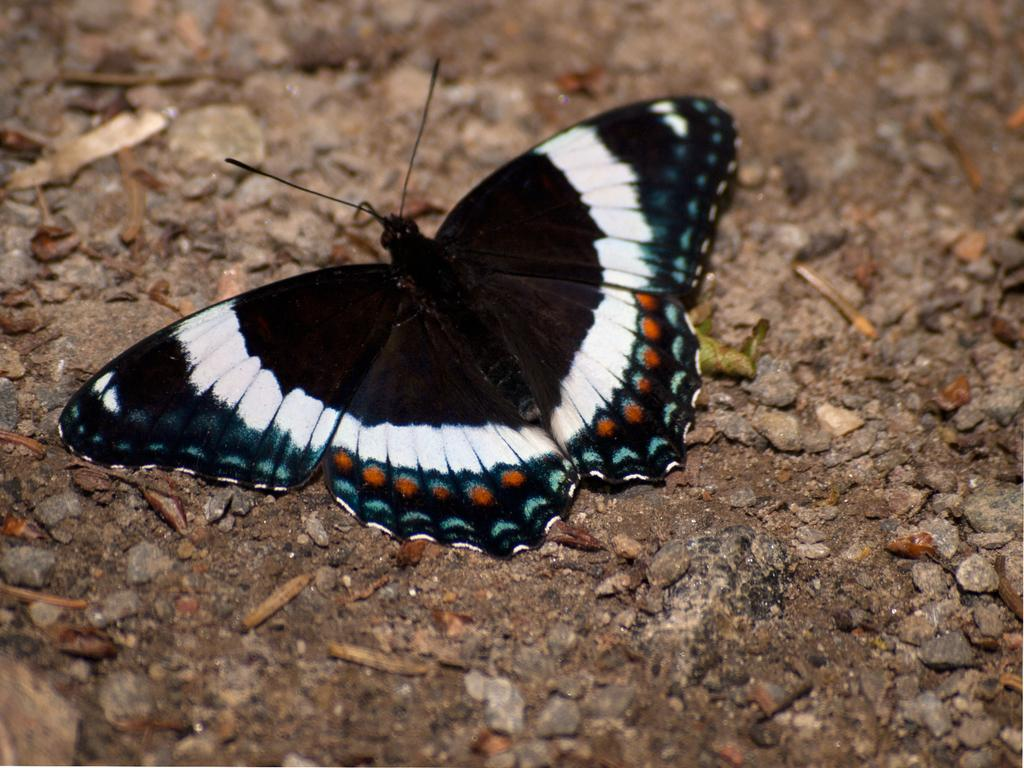What type of animal can be seen in the image? There is a butterfly in the image. What can be seen at the bottom of the image? There are stones visible at the bottom of the image. What type of development is taking place in the image? There is no indication of any development taking place in the image. What season is depicted in the image? The image does not provide any information about the season. 